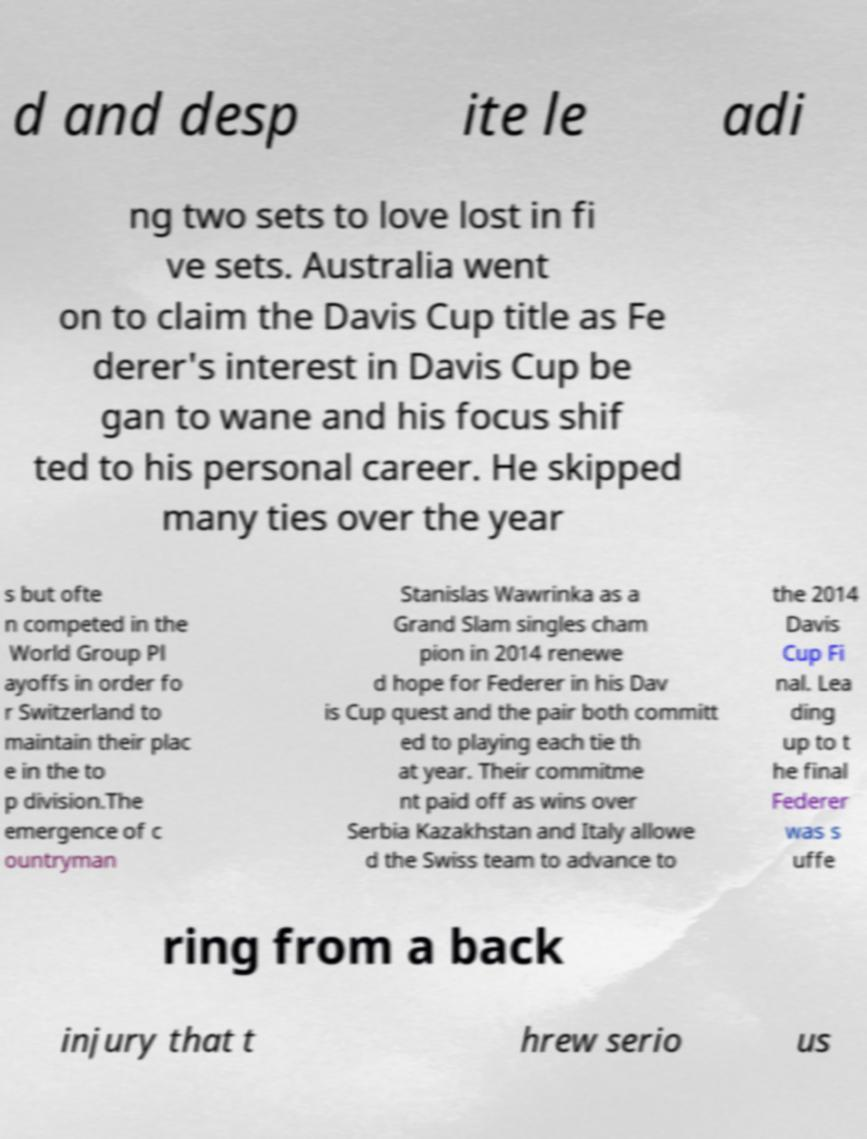For documentation purposes, I need the text within this image transcribed. Could you provide that? d and desp ite le adi ng two sets to love lost in fi ve sets. Australia went on to claim the Davis Cup title as Fe derer's interest in Davis Cup be gan to wane and his focus shif ted to his personal career. He skipped many ties over the year s but ofte n competed in the World Group Pl ayoffs in order fo r Switzerland to maintain their plac e in the to p division.The emergence of c ountryman Stanislas Wawrinka as a Grand Slam singles cham pion in 2014 renewe d hope for Federer in his Dav is Cup quest and the pair both committ ed to playing each tie th at year. Their commitme nt paid off as wins over Serbia Kazakhstan and Italy allowe d the Swiss team to advance to the 2014 Davis Cup Fi nal. Lea ding up to t he final Federer was s uffe ring from a back injury that t hrew serio us 